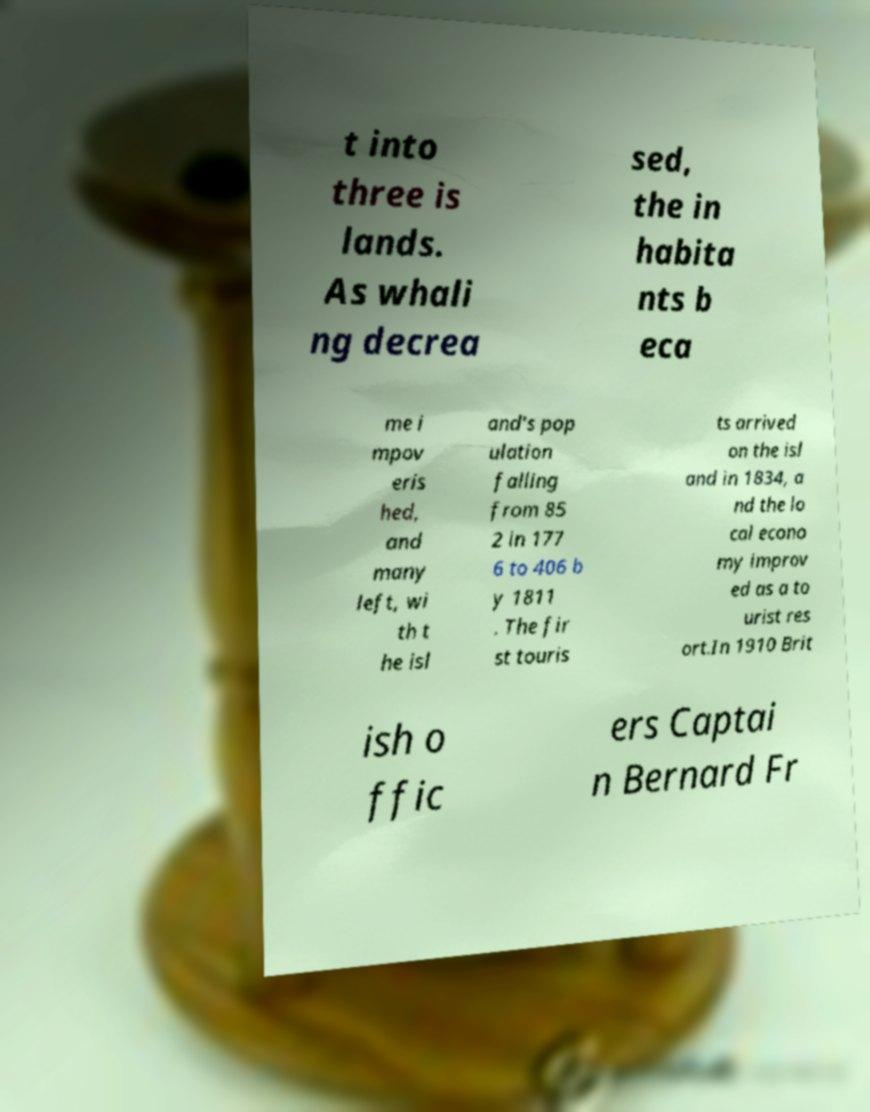What messages or text are displayed in this image? I need them in a readable, typed format. t into three is lands. As whali ng decrea sed, the in habita nts b eca me i mpov eris hed, and many left, wi th t he isl and's pop ulation falling from 85 2 in 177 6 to 406 b y 1811 . The fir st touris ts arrived on the isl and in 1834, a nd the lo cal econo my improv ed as a to urist res ort.In 1910 Brit ish o ffic ers Captai n Bernard Fr 